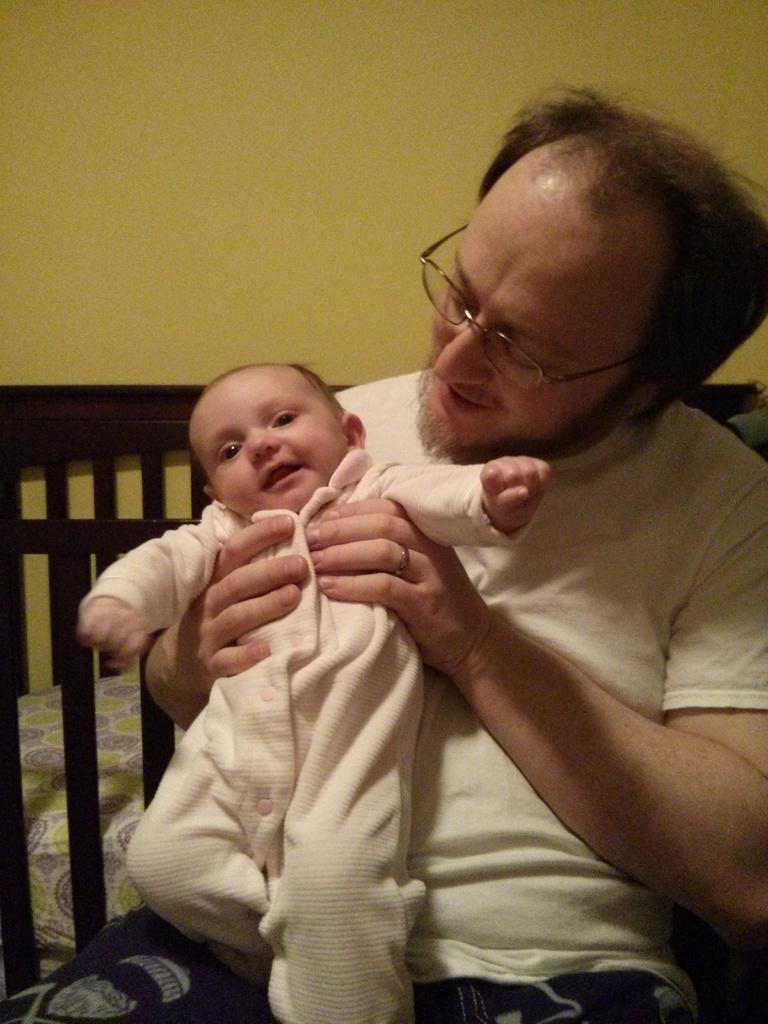Could you give a brief overview of what you see in this image? Here I can see a man wearing white color t-shirt, sitting on the sofa and carrying a baby in the hand and looking at this baby. In the background I can see the wall. 